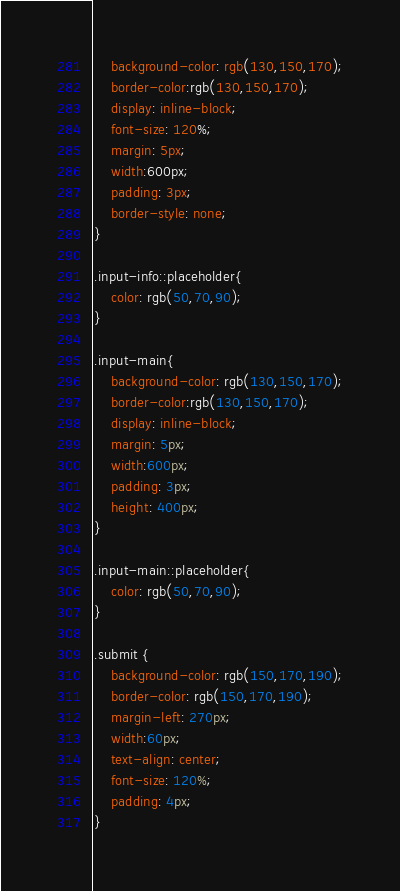Convert code to text. <code><loc_0><loc_0><loc_500><loc_500><_CSS_>	background-color: rgb(130,150,170);
	border-color:rgb(130,150,170);
	display: inline-block;
	font-size: 120%;
	margin: 5px;
	width:600px;
	padding: 3px;
	border-style: none;
}

.input-info::placeholder{
	color: rgb(50,70,90);
}

.input-main{
	background-color: rgb(130,150,170);
	border-color:rgb(130,150,170);
	display: inline-block;
	margin: 5px;
	width:600px;
	padding: 3px;
	height: 400px;
}

.input-main::placeholder{
	color: rgb(50,70,90);
}

.submit {
	background-color: rgb(150,170,190);
	border-color: rgb(150,170,190);
	margin-left: 270px;
	width:60px;
	text-align: center;
	font-size: 120%;
	padding: 4px;
}</code> 